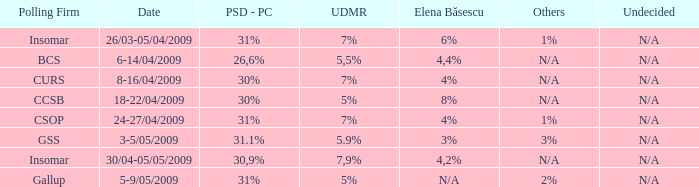When does the 2% addition take place for others? 5-9/05/2009. 